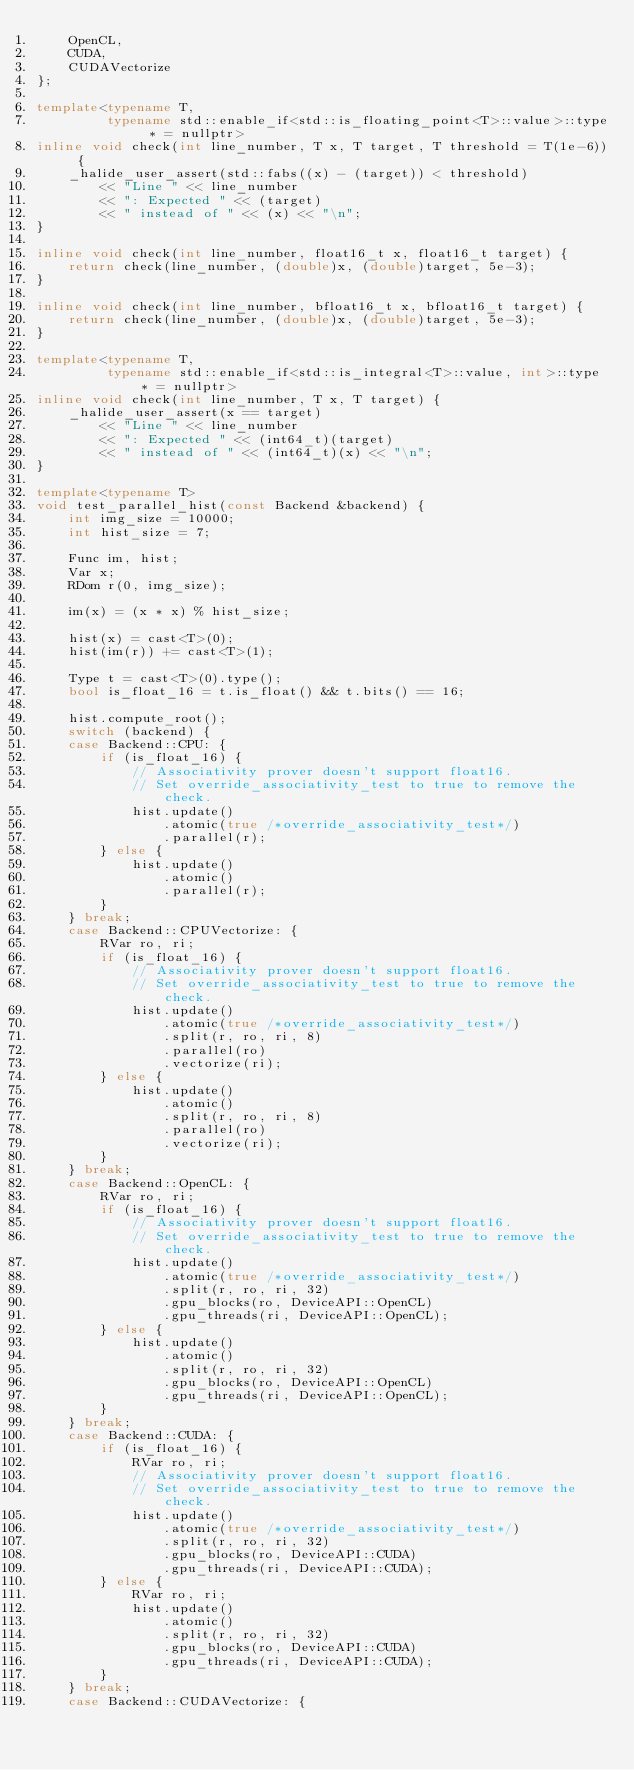<code> <loc_0><loc_0><loc_500><loc_500><_C++_>    OpenCL,
    CUDA,
    CUDAVectorize
};

template<typename T,
         typename std::enable_if<std::is_floating_point<T>::value>::type * = nullptr>
inline void check(int line_number, T x, T target, T threshold = T(1e-6)) {
    _halide_user_assert(std::fabs((x) - (target)) < threshold)
        << "Line " << line_number
        << ": Expected " << (target)
        << " instead of " << (x) << "\n";
}

inline void check(int line_number, float16_t x, float16_t target) {
    return check(line_number, (double)x, (double)target, 5e-3);
}

inline void check(int line_number, bfloat16_t x, bfloat16_t target) {
    return check(line_number, (double)x, (double)target, 5e-3);
}

template<typename T,
         typename std::enable_if<std::is_integral<T>::value, int>::type * = nullptr>
inline void check(int line_number, T x, T target) {
    _halide_user_assert(x == target)
        << "Line " << line_number
        << ": Expected " << (int64_t)(target)
        << " instead of " << (int64_t)(x) << "\n";
}

template<typename T>
void test_parallel_hist(const Backend &backend) {
    int img_size = 10000;
    int hist_size = 7;

    Func im, hist;
    Var x;
    RDom r(0, img_size);

    im(x) = (x * x) % hist_size;

    hist(x) = cast<T>(0);
    hist(im(r)) += cast<T>(1);

    Type t = cast<T>(0).type();
    bool is_float_16 = t.is_float() && t.bits() == 16;

    hist.compute_root();
    switch (backend) {
    case Backend::CPU: {
        if (is_float_16) {
            // Associativity prover doesn't support float16.
            // Set override_associativity_test to true to remove the check.
            hist.update()
                .atomic(true /*override_associativity_test*/)
                .parallel(r);
        } else {
            hist.update()
                .atomic()
                .parallel(r);
        }
    } break;
    case Backend::CPUVectorize: {
        RVar ro, ri;
        if (is_float_16) {
            // Associativity prover doesn't support float16.
            // Set override_associativity_test to true to remove the check.
            hist.update()
                .atomic(true /*override_associativity_test*/)
                .split(r, ro, ri, 8)
                .parallel(ro)
                .vectorize(ri);
        } else {
            hist.update()
                .atomic()
                .split(r, ro, ri, 8)
                .parallel(ro)
                .vectorize(ri);
        }
    } break;
    case Backend::OpenCL: {
        RVar ro, ri;
        if (is_float_16) {
            // Associativity prover doesn't support float16.
            // Set override_associativity_test to true to remove the check.
            hist.update()
                .atomic(true /*override_associativity_test*/)
                .split(r, ro, ri, 32)
                .gpu_blocks(ro, DeviceAPI::OpenCL)
                .gpu_threads(ri, DeviceAPI::OpenCL);
        } else {
            hist.update()
                .atomic()
                .split(r, ro, ri, 32)
                .gpu_blocks(ro, DeviceAPI::OpenCL)
                .gpu_threads(ri, DeviceAPI::OpenCL);
        }
    } break;
    case Backend::CUDA: {
        if (is_float_16) {
            RVar ro, ri;
            // Associativity prover doesn't support float16.
            // Set override_associativity_test to true to remove the check.
            hist.update()
                .atomic(true /*override_associativity_test*/)
                .split(r, ro, ri, 32)
                .gpu_blocks(ro, DeviceAPI::CUDA)
                .gpu_threads(ri, DeviceAPI::CUDA);
        } else {
            RVar ro, ri;
            hist.update()
                .atomic()
                .split(r, ro, ri, 32)
                .gpu_blocks(ro, DeviceAPI::CUDA)
                .gpu_threads(ri, DeviceAPI::CUDA);
        }
    } break;
    case Backend::CUDAVectorize: {</code> 